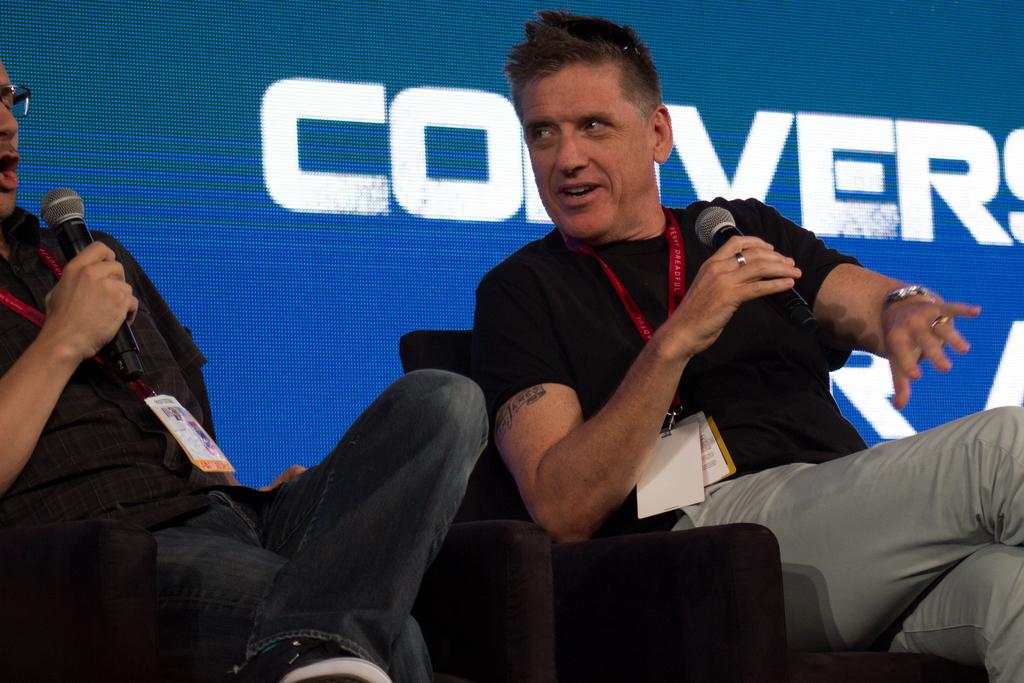How many people are in the image? There are two persons in the image. What are the persons holding in their hands? The persons are holding microphones. What can be seen on the persons' clothing? The persons are wearing ID cards. What are the persons sitting on in the image? The persons are sitting on chairs. What is visible on the screen in the background of the image? There is a screen with text in the background of the image. What type of prison can be seen in the image? There is no prison present in the image. What time of day is it in the image? The time of day cannot be determined from the image. 